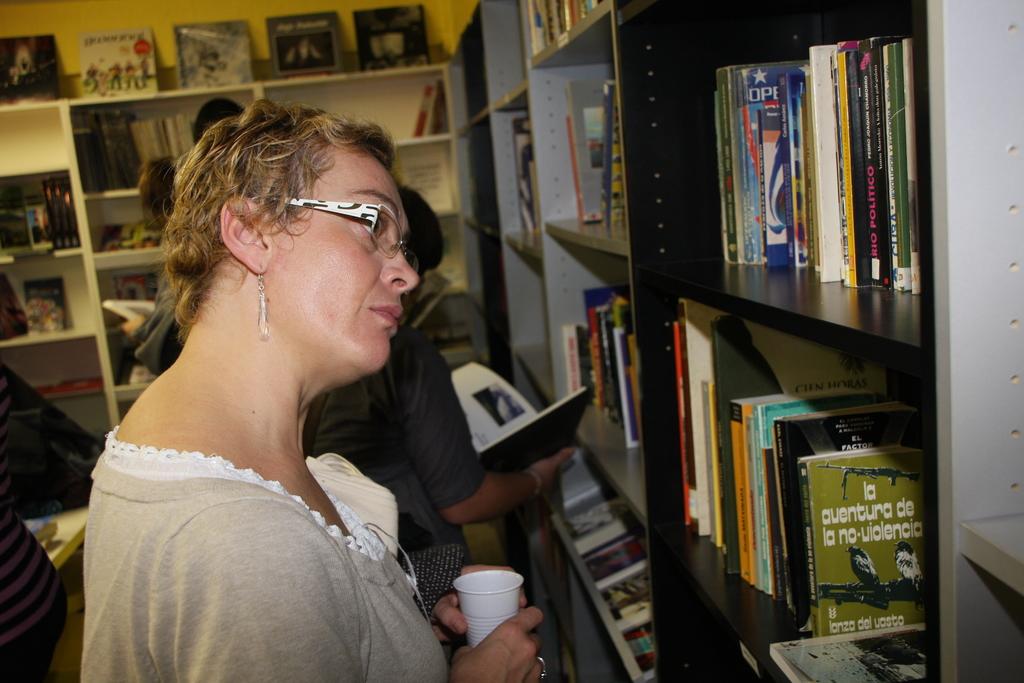What is the title of that green book?
Your answer should be compact. La aventura de la no-violencia. 